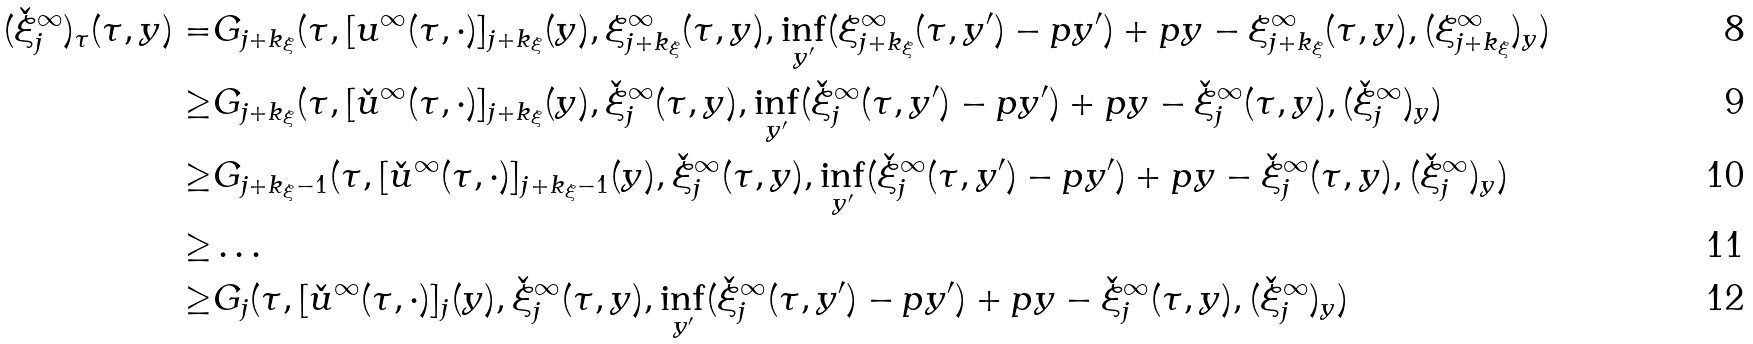<formula> <loc_0><loc_0><loc_500><loc_500>( \check { \xi } _ { j } ^ { \infty } ) _ { \tau } ( \tau , y ) = & G _ { j + k _ { \xi } } ( \tau , [ u ^ { \infty } ( \tau , \cdot ) ] _ { j + k _ { \xi } } ( y ) , \xi _ { j + k _ { \xi } } ^ { \infty } ( \tau , y ) , \inf _ { y ^ { \prime } } ( \xi _ { j + k _ { \xi } } ^ { \infty } ( \tau , y ^ { \prime } ) - p y ^ { \prime } ) + p y - \xi _ { j + k _ { \xi } } ^ { \infty } ( \tau , y ) , ( \xi _ { j + k _ { \xi } } ^ { \infty } ) _ { y } ) \\ \geq & G _ { j + k _ { \xi } } ( \tau , [ \check { u } ^ { \infty } ( \tau , \cdot ) ] _ { j + k _ { \xi } } ( y ) , \check { \xi } _ { j } ^ { \infty } ( \tau , y ) , \inf _ { y ^ { \prime } } ( \check { \xi } _ { j } ^ { \infty } ( \tau , y ^ { \prime } ) - p y ^ { \prime } ) + p y - \check { \xi } _ { j } ^ { \infty } ( \tau , y ) , ( \check { \xi } _ { j } ^ { \infty } ) _ { y } ) \\ \geq & G _ { j + k _ { \xi } - 1 } ( \tau , [ \check { u } ^ { \infty } ( \tau , \cdot ) ] _ { j + k _ { \xi } - 1 } ( y ) , \check { \xi } _ { j } ^ { \infty } ( \tau , y ) , \inf _ { y ^ { \prime } } ( \check { \xi } _ { j } ^ { \infty } ( \tau , y ^ { \prime } ) - p y ^ { \prime } ) + p y - \check { \xi } _ { j } ^ { \infty } ( \tau , y ) , ( \check { \xi } _ { j } ^ { \infty } ) _ { y } ) \\ \geq & \dots \\ \geq & G _ { j } ( \tau , [ \check { u } ^ { \infty } ( \tau , \cdot ) ] _ { j } ( y ) , \check { \xi } _ { j } ^ { \infty } ( \tau , y ) , \inf _ { y ^ { \prime } } ( \check { \xi } _ { j } ^ { \infty } ( \tau , y ^ { \prime } ) - p y ^ { \prime } ) + p y - \check { \xi } _ { j } ^ { \infty } ( \tau , y ) , ( \check { \xi } _ { j } ^ { \infty } ) _ { y } )</formula> 